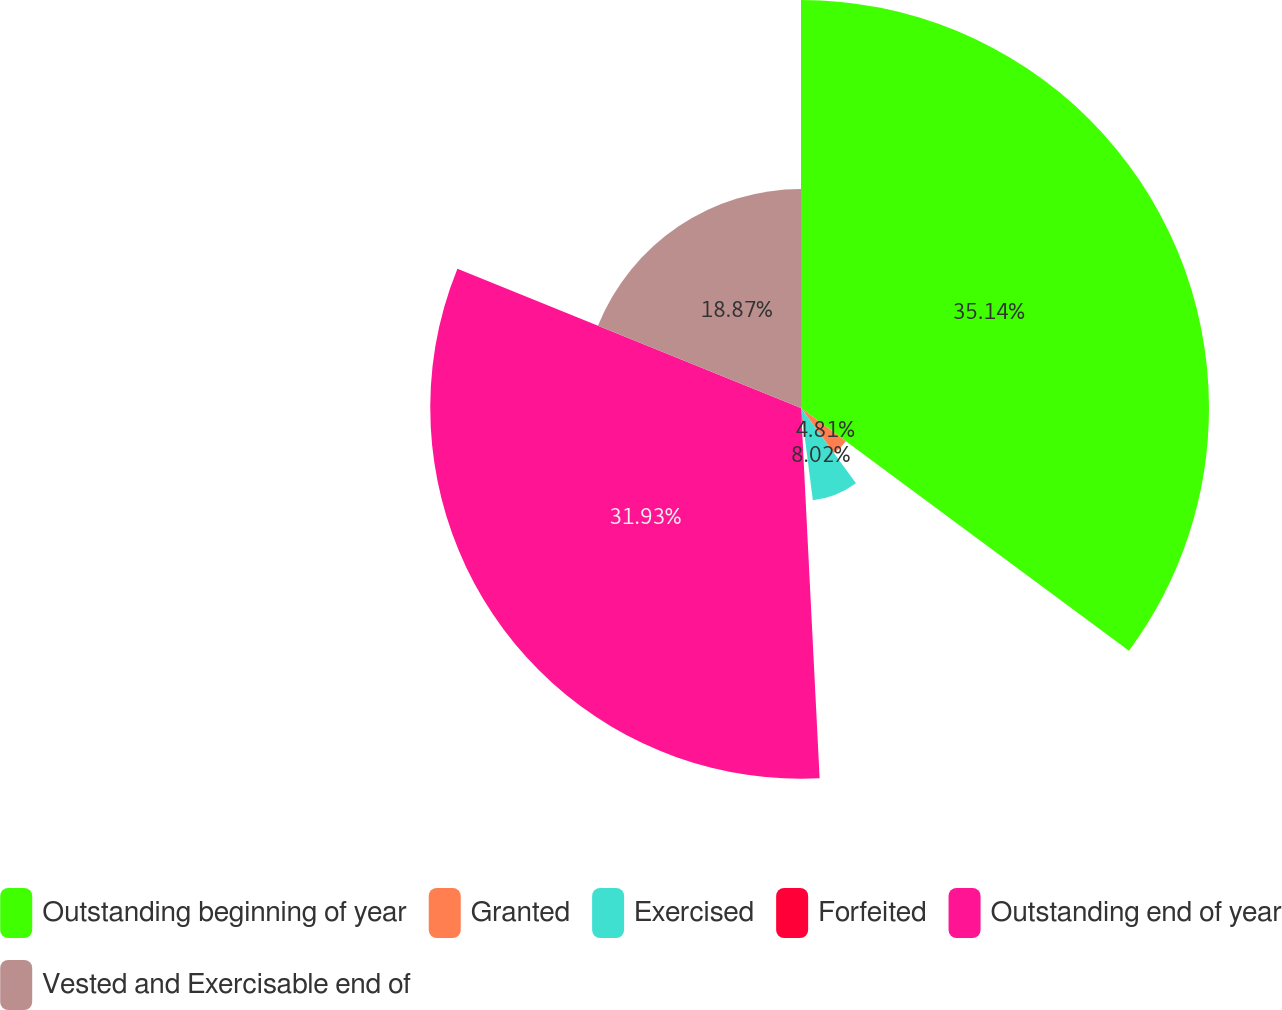<chart> <loc_0><loc_0><loc_500><loc_500><pie_chart><fcel>Outstanding beginning of year<fcel>Granted<fcel>Exercised<fcel>Forfeited<fcel>Outstanding end of year<fcel>Vested and Exercisable end of<nl><fcel>35.14%<fcel>4.81%<fcel>8.02%<fcel>1.23%<fcel>31.93%<fcel>18.87%<nl></chart> 